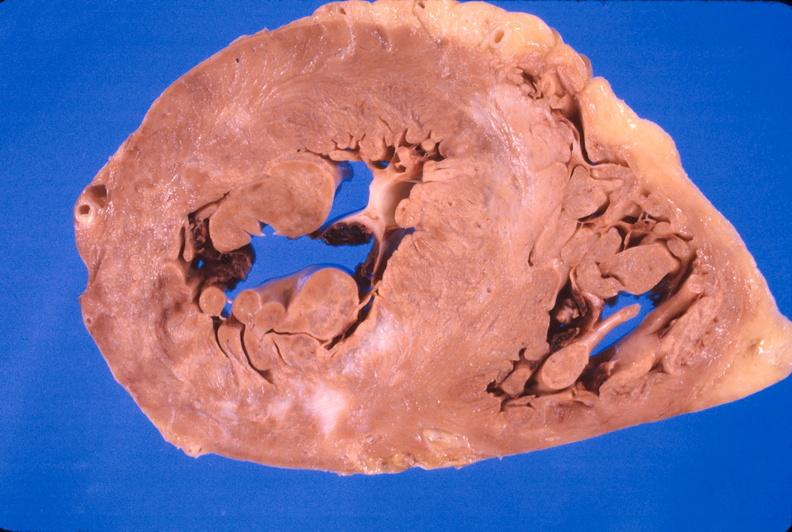does this image show heart, myocardial infarction free wall, 6 days old, in a patient with diabetes mellitus and hypertension?
Answer the question using a single word or phrase. Yes 